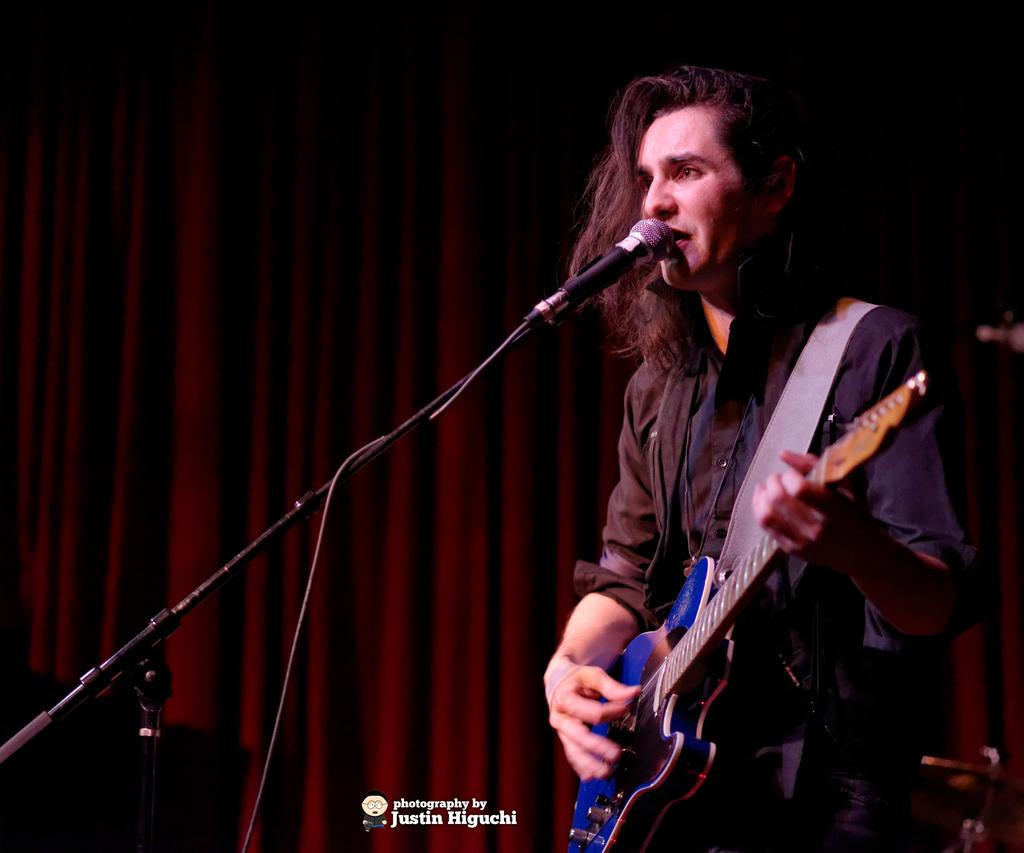What is the person in the image doing? The person is playing a guitar. What object is the person in front of? The person is in front of a microphone. What can be seen in the background of the image? There are curtains in the background of the image. What type of vessel is being used to control the rate of the person's turn in the image? There is no vessel or turning action present in the image; it features a person playing a guitar in front of a microphone with curtains in the background. 